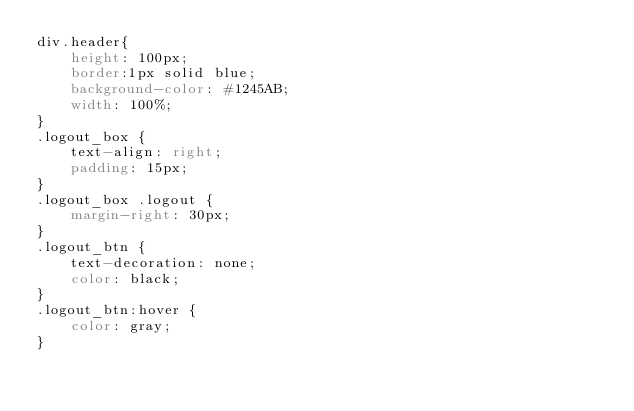Convert code to text. <code><loc_0><loc_0><loc_500><loc_500><_CSS_>div.header{
	height: 100px;
	border:1px solid blue;
	background-color: #1245AB;
	width: 100%;
}
.logout_box {
	text-align: right;
	padding: 15px;
}
.logout_box .logout {
	margin-right: 30px;
}
.logout_btn {
	text-decoration: none;
	color: black;
}
.logout_btn:hover {
	color: gray;
}</code> 